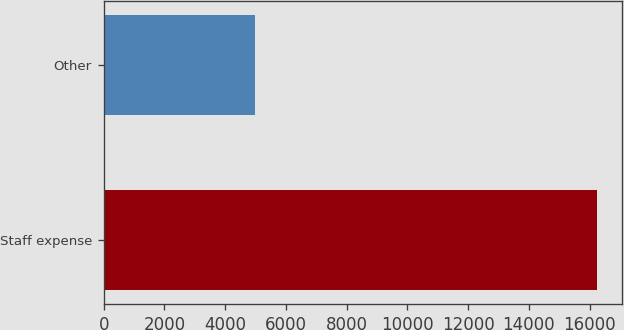<chart> <loc_0><loc_0><loc_500><loc_500><bar_chart><fcel>Staff expense<fcel>Other<nl><fcel>16255<fcel>4974<nl></chart> 